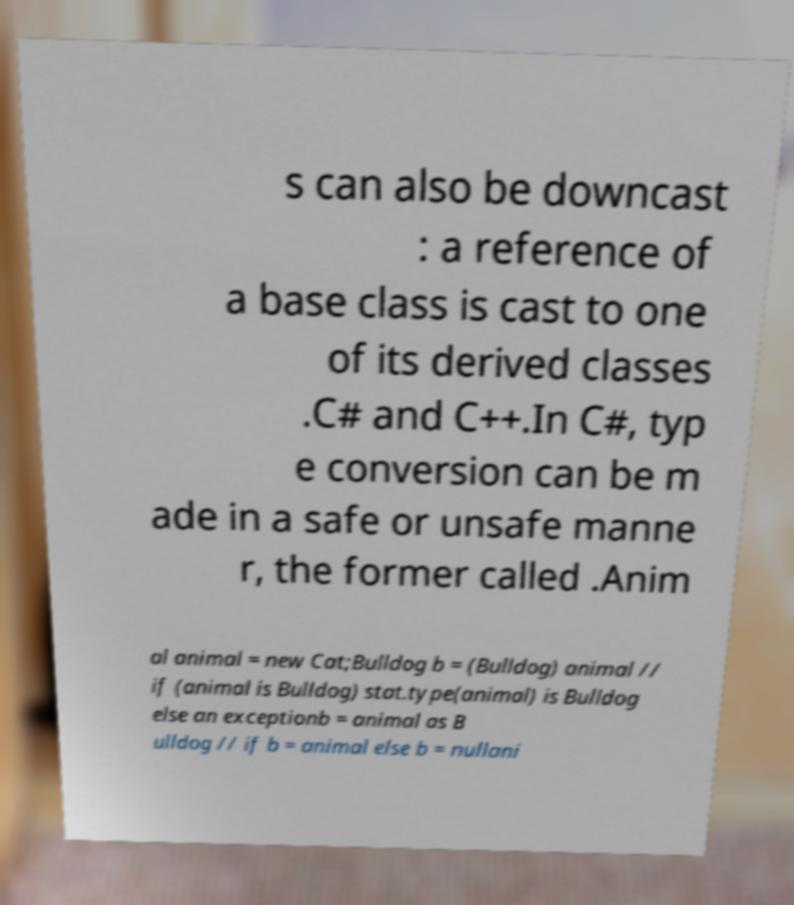Could you assist in decoding the text presented in this image and type it out clearly? s can also be downcast : a reference of a base class is cast to one of its derived classes .C# and C++.In C#, typ e conversion can be m ade in a safe or unsafe manne r, the former called .Anim al animal = new Cat;Bulldog b = (Bulldog) animal // if (animal is Bulldog) stat.type(animal) is Bulldog else an exceptionb = animal as B ulldog // if b = animal else b = nullani 